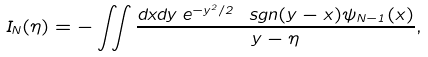<formula> <loc_0><loc_0><loc_500><loc_500>I _ { N } ( \eta ) = - \iint \frac { d x d y \, e ^ { - y ^ { 2 } / 2 } \ s g n ( y - x ) \psi _ { N - 1 } ( x ) } { y - \eta } ,</formula> 